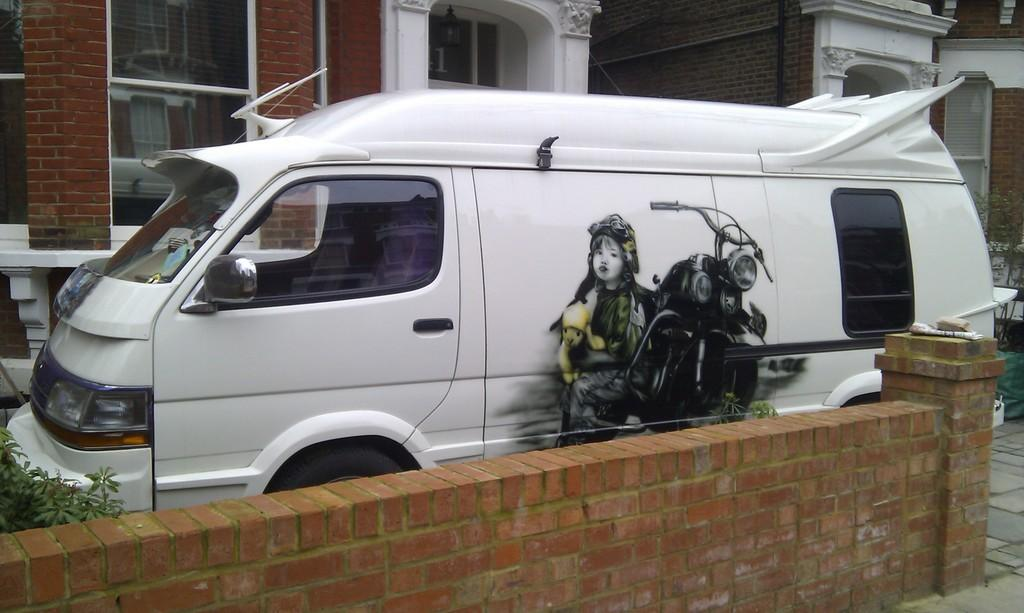What is the main subject in the center of the image? There is a van in the center of the image. What is located at the bottom of the image? There is a wall at the bottom of the image. What can be seen in the background of the image? There is a building in the background of the image. Can you identify any openings in the image? Yes, there is a window visible in the image. What type of gold bulb can be seen hanging from the van in the image? There is no gold bulb present in the image; the van and the other elements mentioned in the facts are the only visible objects. 